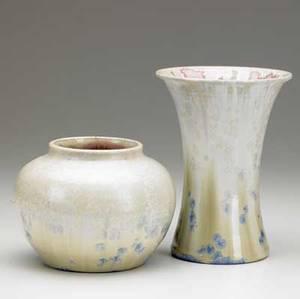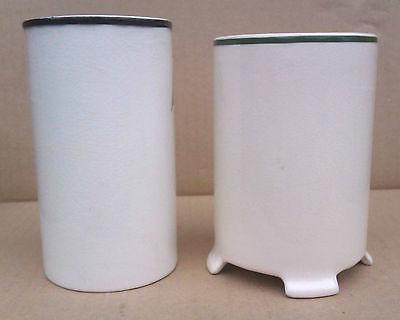The first image is the image on the left, the second image is the image on the right. Analyze the images presented: Is the assertion "There are four pieces of pottery with four holes." valid? Answer yes or no. Yes. The first image is the image on the left, the second image is the image on the right. Given the left and right images, does the statement "There are four white vases standing in groups of two." hold true? Answer yes or no. Yes. 